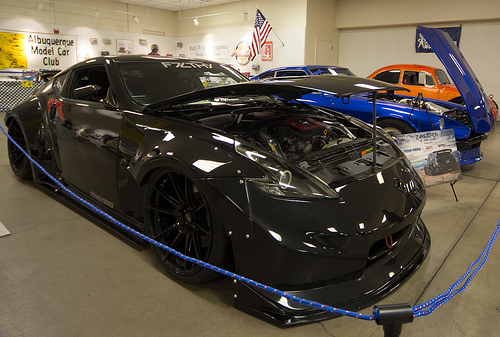<image>
Is the car behind the rope? Yes. From this viewpoint, the car is positioned behind the rope, with the rope partially or fully occluding the car. 